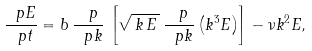<formula> <loc_0><loc_0><loc_500><loc_500>\frac { \ p E } { \ p t } = b \, \frac { \ p } { \ p k } \, \left [ \sqrt { \, k \, E \, } \, \frac { \ p } { \ p k } \left ( k ^ { 3 } E \right ) \right ] - \nu k ^ { 2 } E ,</formula> 